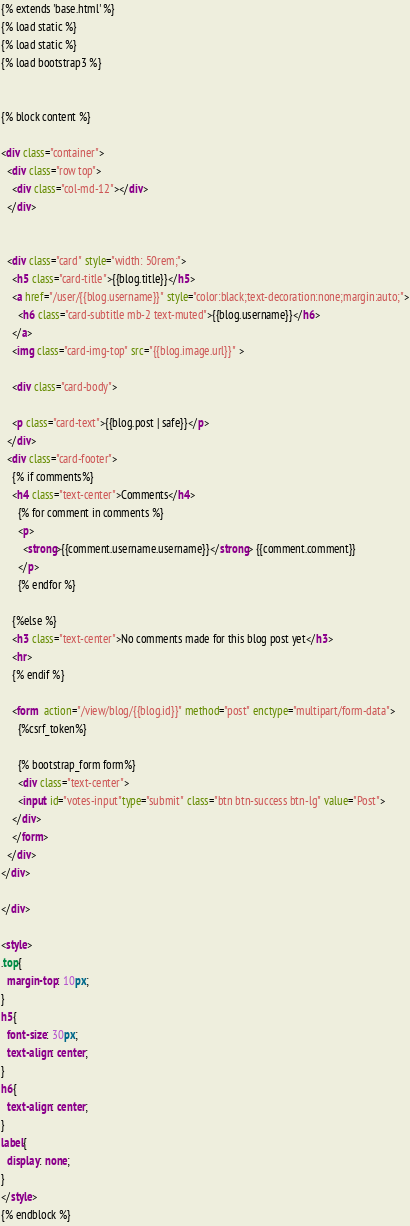Convert code to text. <code><loc_0><loc_0><loc_500><loc_500><_HTML_>{% extends 'base.html' %}
{% load static %}
{% load static %}
{% load bootstrap3 %}


{% block content %}

<div class="container">
  <div class="row top">
    <div class="col-md-12"></div>
  </div>


  <div class="card" style="width: 50rem;">
    <h5 class="card-title">{{blog.title}}</h5>
    <a href="/user/{{blog.username}}" style="color:black;text-decoration:none;margin:auto;">
      <h6 class="card-subtitle mb-2 text-muted">{{blog.username}}</h6>
    </a>
    <img class="card-img-top" src="{{blog.image.url}}" >

    <div class="card-body">

    <p class="card-text">{{blog.post | safe}}</p>
  </div>
  <div class="card-footer">
    {% if comments%}
    <h4 class="text-center">Comments</h4>
      {% for comment in comments %}
      <p>
        <strong>{{comment.username.username}}</strong> {{comment.comment}}
      </p>
      {% endfor %}

    {%else %}
    <h3 class="text-center">No comments made for this blog post yet</h3>
    <hr>
    {% endif %}

    <form  action="/view/blog/{{blog.id}}" method="post" enctype="multipart/form-data">
      {%csrf_token%}

      {% bootstrap_form form%}
      <div class="text-center">
      <input id="votes-input"type="submit" class="btn btn-success btn-lg" value="Post">
    </div>
    </form>
  </div>
</div>

</div>

<style>
.top{
  margin-top: 10px;
}
h5{
  font-size: 30px;
  text-align: center;
}
h6{
  text-align: center;
}
label{
  display: none;
}
</style>
{% endblock %}
</code> 